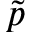<formula> <loc_0><loc_0><loc_500><loc_500>\widetilde { p }</formula> 